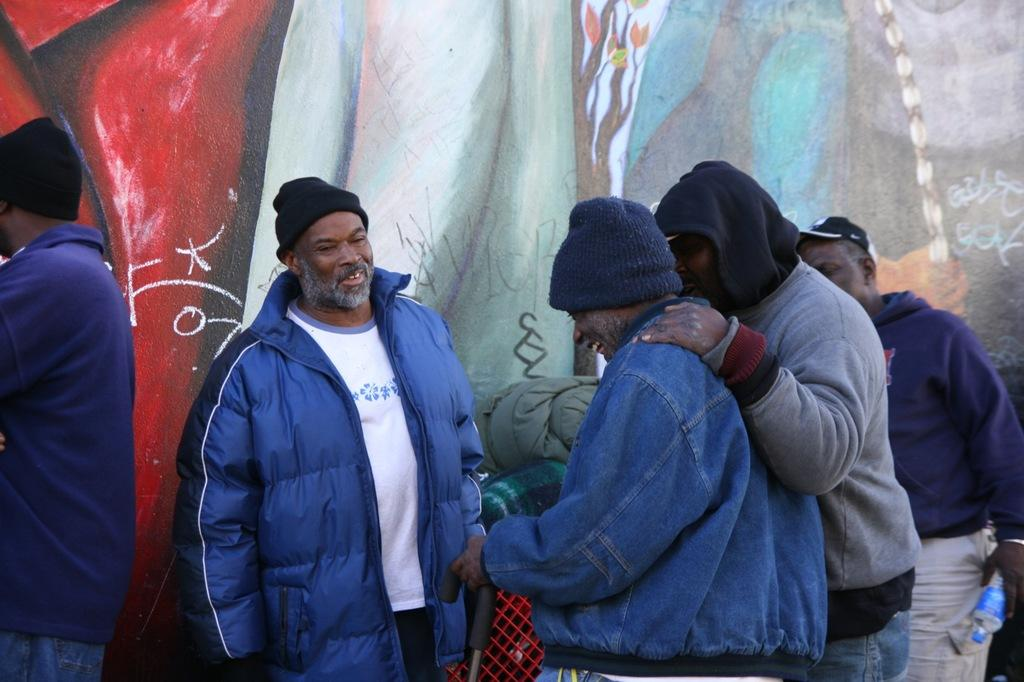How many people are present in the image? There are five people in the image. What else can be seen in the image besides the people? There are objects in the image. Can you describe the background of the image? There is a painting on the wall in the background of the image. What type of wine is being served in the image? There is no wine present in the image. How does the shock affect the people in the image? There is no shock present in the image, so it cannot affect the people. 